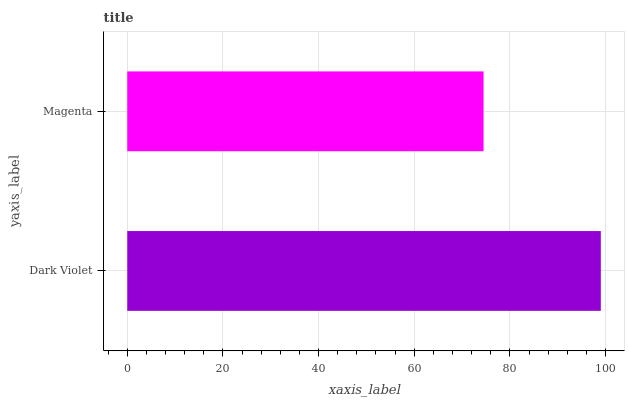Is Magenta the minimum?
Answer yes or no. Yes. Is Dark Violet the maximum?
Answer yes or no. Yes. Is Magenta the maximum?
Answer yes or no. No. Is Dark Violet greater than Magenta?
Answer yes or no. Yes. Is Magenta less than Dark Violet?
Answer yes or no. Yes. Is Magenta greater than Dark Violet?
Answer yes or no. No. Is Dark Violet less than Magenta?
Answer yes or no. No. Is Dark Violet the high median?
Answer yes or no. Yes. Is Magenta the low median?
Answer yes or no. Yes. Is Magenta the high median?
Answer yes or no. No. Is Dark Violet the low median?
Answer yes or no. No. 